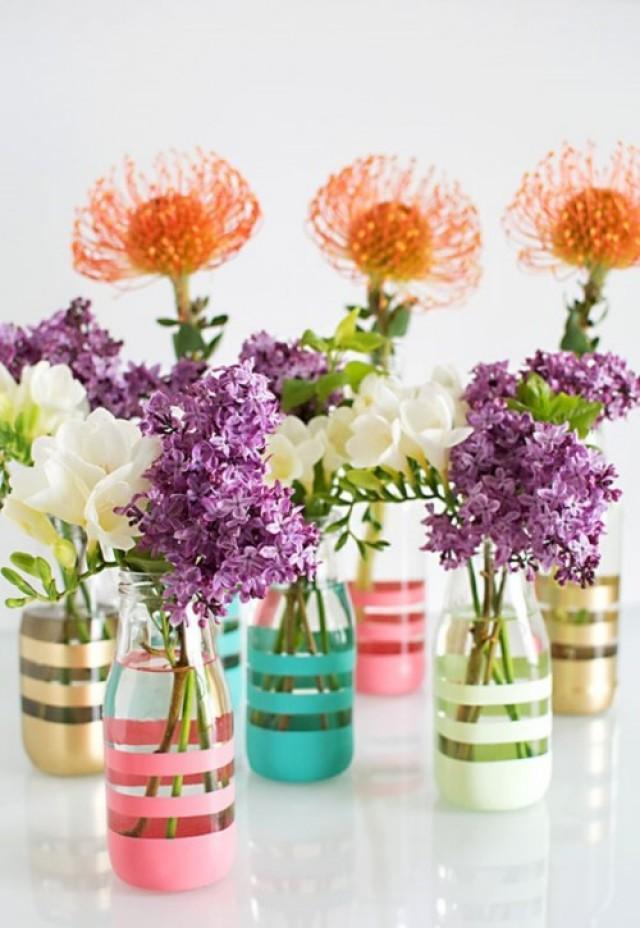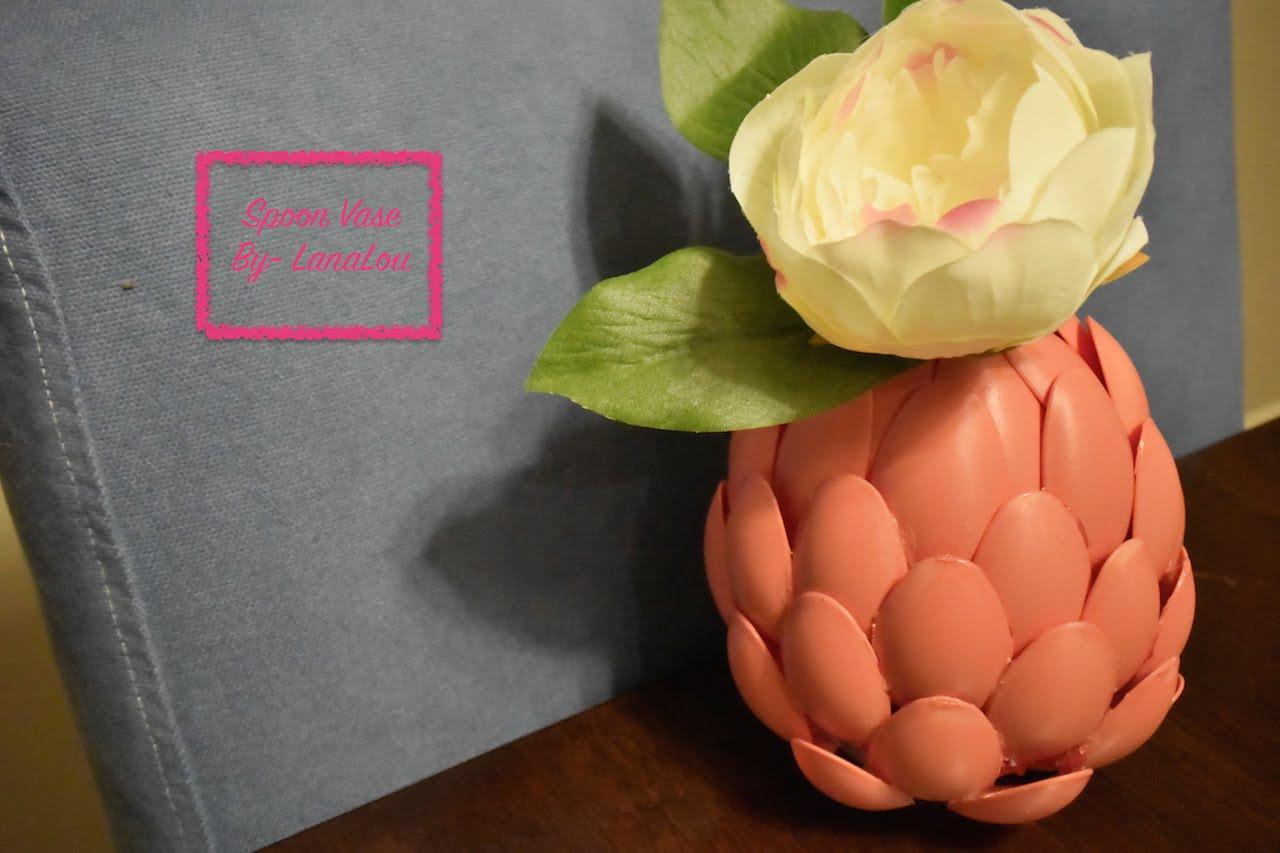The first image is the image on the left, the second image is the image on the right. Considering the images on both sides, is "Every container is either white or clear" valid? Answer yes or no. No. The first image is the image on the left, the second image is the image on the right. Given the left and right images, does the statement "Some of the vases are see-thru; you can see the stems through the vase walls." hold true? Answer yes or no. Yes. 